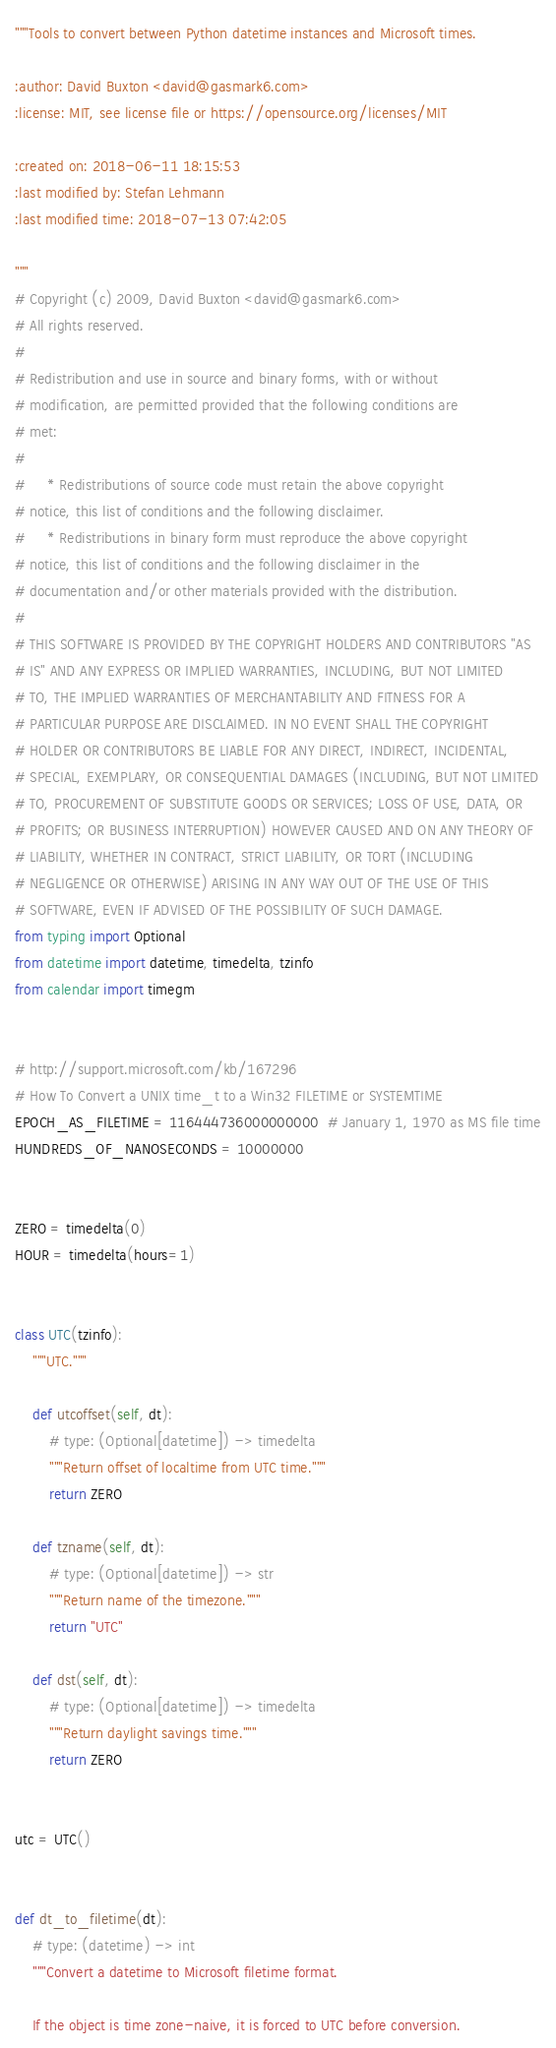<code> <loc_0><loc_0><loc_500><loc_500><_Python_>"""Tools to convert between Python datetime instances and Microsoft times.

:author: David Buxton <david@gasmark6.com>
:license: MIT, see license file or https://opensource.org/licenses/MIT

:created on: 2018-06-11 18:15:53
:last modified by: Stefan Lehmann
:last modified time: 2018-07-13 07:42:05

"""
# Copyright (c) 2009, David Buxton <david@gasmark6.com>
# All rights reserved.
#
# Redistribution and use in source and binary forms, with or without
# modification, are permitted provided that the following conditions are
# met:
#
#     * Redistributions of source code must retain the above copyright
# notice, this list of conditions and the following disclaimer.
#     * Redistributions in binary form must reproduce the above copyright
# notice, this list of conditions and the following disclaimer in the
# documentation and/or other materials provided with the distribution.
#
# THIS SOFTWARE IS PROVIDED BY THE COPYRIGHT HOLDERS AND CONTRIBUTORS "AS
# IS" AND ANY EXPRESS OR IMPLIED WARRANTIES, INCLUDING, BUT NOT LIMITED
# TO, THE IMPLIED WARRANTIES OF MERCHANTABILITY AND FITNESS FOR A
# PARTICULAR PURPOSE ARE DISCLAIMED. IN NO EVENT SHALL THE COPYRIGHT
# HOLDER OR CONTRIBUTORS BE LIABLE FOR ANY DIRECT, INDIRECT, INCIDENTAL,
# SPECIAL, EXEMPLARY, OR CONSEQUENTIAL DAMAGES (INCLUDING, BUT NOT LIMITED
# TO, PROCUREMENT OF SUBSTITUTE GOODS OR SERVICES; LOSS OF USE, DATA, OR
# PROFITS; OR BUSINESS INTERRUPTION) HOWEVER CAUSED AND ON ANY THEORY OF
# LIABILITY, WHETHER IN CONTRACT, STRICT LIABILITY, OR TORT (INCLUDING
# NEGLIGENCE OR OTHERWISE) ARISING IN ANY WAY OUT OF THE USE OF THIS
# SOFTWARE, EVEN IF ADVISED OF THE POSSIBILITY OF SUCH DAMAGE.
from typing import Optional
from datetime import datetime, timedelta, tzinfo
from calendar import timegm


# http://support.microsoft.com/kb/167296
# How To Convert a UNIX time_t to a Win32 FILETIME or SYSTEMTIME
EPOCH_AS_FILETIME = 116444736000000000  # January 1, 1970 as MS file time
HUNDREDS_OF_NANOSECONDS = 10000000


ZERO = timedelta(0)
HOUR = timedelta(hours=1)


class UTC(tzinfo):
    """UTC."""

    def utcoffset(self, dt):
        # type: (Optional[datetime]) -> timedelta
        """Return offset of localtime from UTC time."""
        return ZERO

    def tzname(self, dt):
        # type: (Optional[datetime]) -> str
        """Return name of the timezone."""
        return "UTC"

    def dst(self, dt):
        # type: (Optional[datetime]) -> timedelta
        """Return daylight savings time."""
        return ZERO


utc = UTC()


def dt_to_filetime(dt):
    # type: (datetime) -> int
    """Convert a datetime to Microsoft filetime format.

    If the object is time zone-naive, it is forced to UTC before conversion.
</code> 